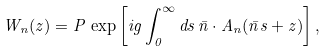<formula> <loc_0><loc_0><loc_500><loc_500>W _ { n } ( z ) = P \, \exp \left [ i g \int _ { 0 } ^ { \infty } d s \, \bar { n } \cdot A _ { n } ( \bar { n } s + z ) \right ] ,</formula> 